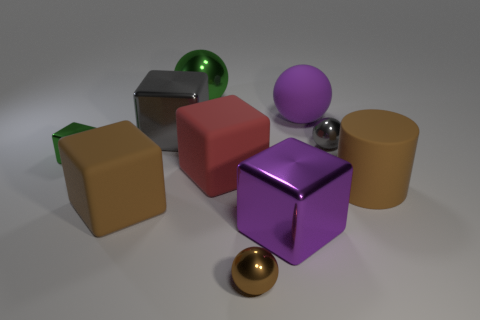Subtract all red cubes. How many cubes are left? 4 Subtract all purple blocks. How many blocks are left? 4 Subtract all blue blocks. Subtract all purple cylinders. How many blocks are left? 5 Subtract all cylinders. How many objects are left? 9 Subtract 1 brown cylinders. How many objects are left? 9 Subtract all big spheres. Subtract all purple rubber objects. How many objects are left? 7 Add 5 cubes. How many cubes are left? 10 Add 4 gray balls. How many gray balls exist? 5 